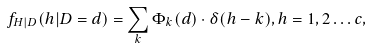Convert formula to latex. <formula><loc_0><loc_0><loc_500><loc_500>f _ { H | D } ( h | D = d ) = \sum _ { k } { \Phi _ { k } ( d ) \cdot \delta ( h - k ) } , h = 1 , 2 \dots c ,</formula> 